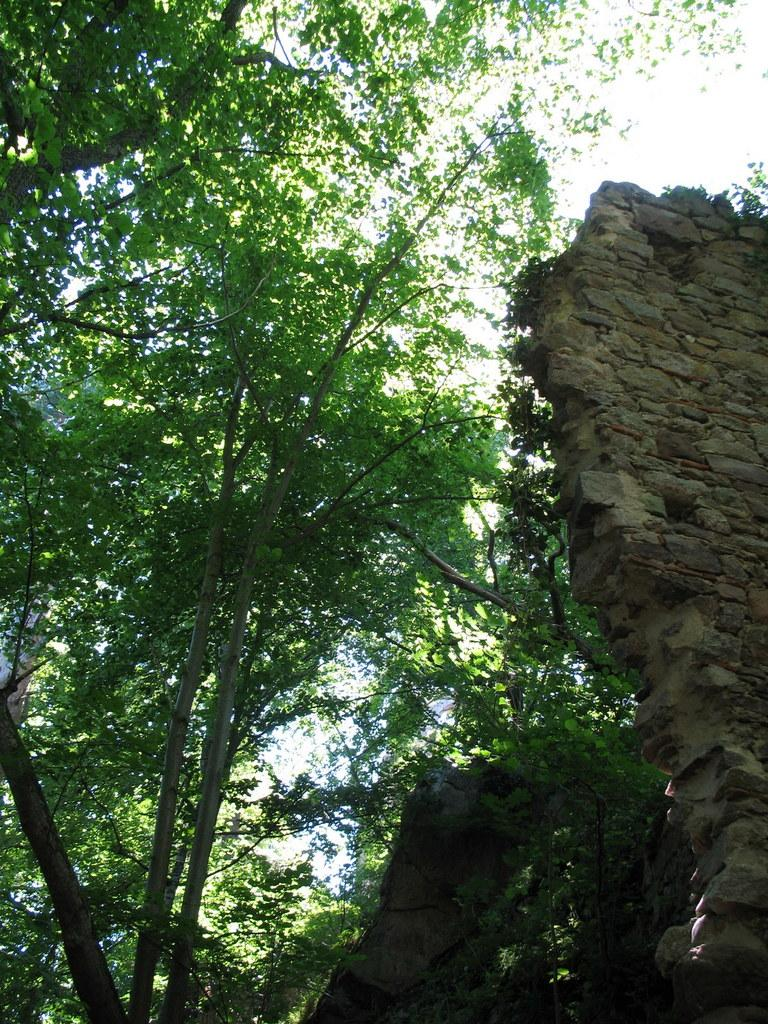What type of vegetation can be seen in the image? There are trees in the image. What material is the wall made of in the image? The wall in the image is made of stones. What is visible in the background of the image? The sky is visible in the image. What type of celery can be seen growing on the wall in the image? There is no celery present in the image, and the wall is made of stones, not a growing medium for celery. Can you tell me the title of the book that is lying on the ground in the image? There is no book present in the image. 